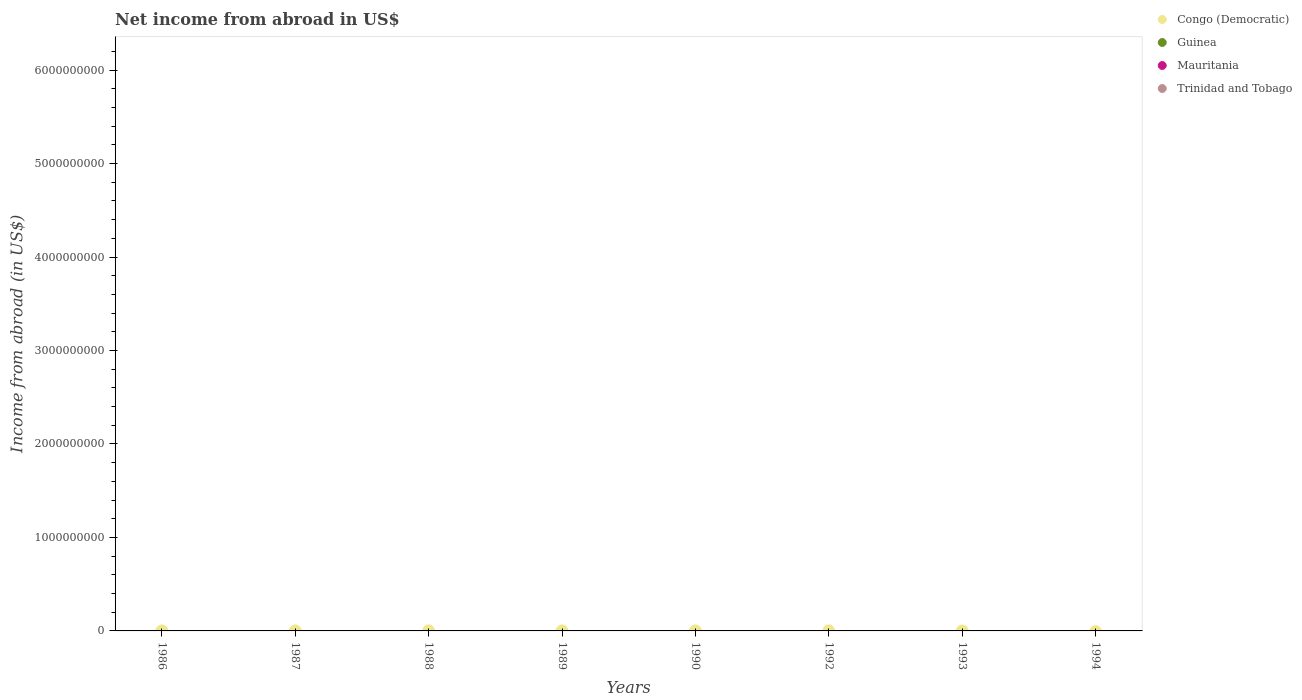How many different coloured dotlines are there?
Provide a short and direct response. 0. Across all years, what is the minimum net income from abroad in Mauritania?
Make the answer very short. 0. What is the total net income from abroad in Guinea in the graph?
Your answer should be very brief. 0. What is the average net income from abroad in Mauritania per year?
Ensure brevity in your answer.  0. In how many years, is the net income from abroad in Mauritania greater than 1600000000 US$?
Your answer should be very brief. 0. Is it the case that in every year, the sum of the net income from abroad in Mauritania and net income from abroad in Guinea  is greater than the net income from abroad in Congo (Democratic)?
Provide a short and direct response. No. Is the net income from abroad in Trinidad and Tobago strictly greater than the net income from abroad in Congo (Democratic) over the years?
Provide a succinct answer. No. How many dotlines are there?
Ensure brevity in your answer.  0. How many years are there in the graph?
Give a very brief answer. 8. What is the difference between two consecutive major ticks on the Y-axis?
Your response must be concise. 1.00e+09. Are the values on the major ticks of Y-axis written in scientific E-notation?
Provide a short and direct response. No. Does the graph contain any zero values?
Give a very brief answer. Yes. Does the graph contain grids?
Your answer should be compact. No. Where does the legend appear in the graph?
Your answer should be compact. Top right. What is the title of the graph?
Ensure brevity in your answer.  Net income from abroad in US$. What is the label or title of the X-axis?
Ensure brevity in your answer.  Years. What is the label or title of the Y-axis?
Make the answer very short. Income from abroad (in US$). What is the Income from abroad (in US$) in Trinidad and Tobago in 1986?
Give a very brief answer. 0. What is the Income from abroad (in US$) of Trinidad and Tobago in 1987?
Keep it short and to the point. 0. What is the Income from abroad (in US$) of Congo (Democratic) in 1988?
Provide a short and direct response. 0. What is the Income from abroad (in US$) in Guinea in 1988?
Offer a very short reply. 0. What is the Income from abroad (in US$) in Mauritania in 1988?
Ensure brevity in your answer.  0. What is the Income from abroad (in US$) in Trinidad and Tobago in 1988?
Your response must be concise. 0. What is the Income from abroad (in US$) in Congo (Democratic) in 1989?
Ensure brevity in your answer.  0. What is the Income from abroad (in US$) of Trinidad and Tobago in 1989?
Provide a succinct answer. 0. What is the Income from abroad (in US$) in Mauritania in 1990?
Provide a short and direct response. 0. What is the Income from abroad (in US$) of Trinidad and Tobago in 1990?
Offer a very short reply. 0. What is the Income from abroad (in US$) in Guinea in 1992?
Your answer should be very brief. 0. What is the Income from abroad (in US$) in Mauritania in 1992?
Your answer should be compact. 0. What is the Income from abroad (in US$) in Trinidad and Tobago in 1992?
Provide a short and direct response. 0. What is the Income from abroad (in US$) of Trinidad and Tobago in 1993?
Your response must be concise. 0. What is the Income from abroad (in US$) of Mauritania in 1994?
Make the answer very short. 0. What is the total Income from abroad (in US$) of Trinidad and Tobago in the graph?
Your response must be concise. 0. What is the average Income from abroad (in US$) of Guinea per year?
Make the answer very short. 0. 